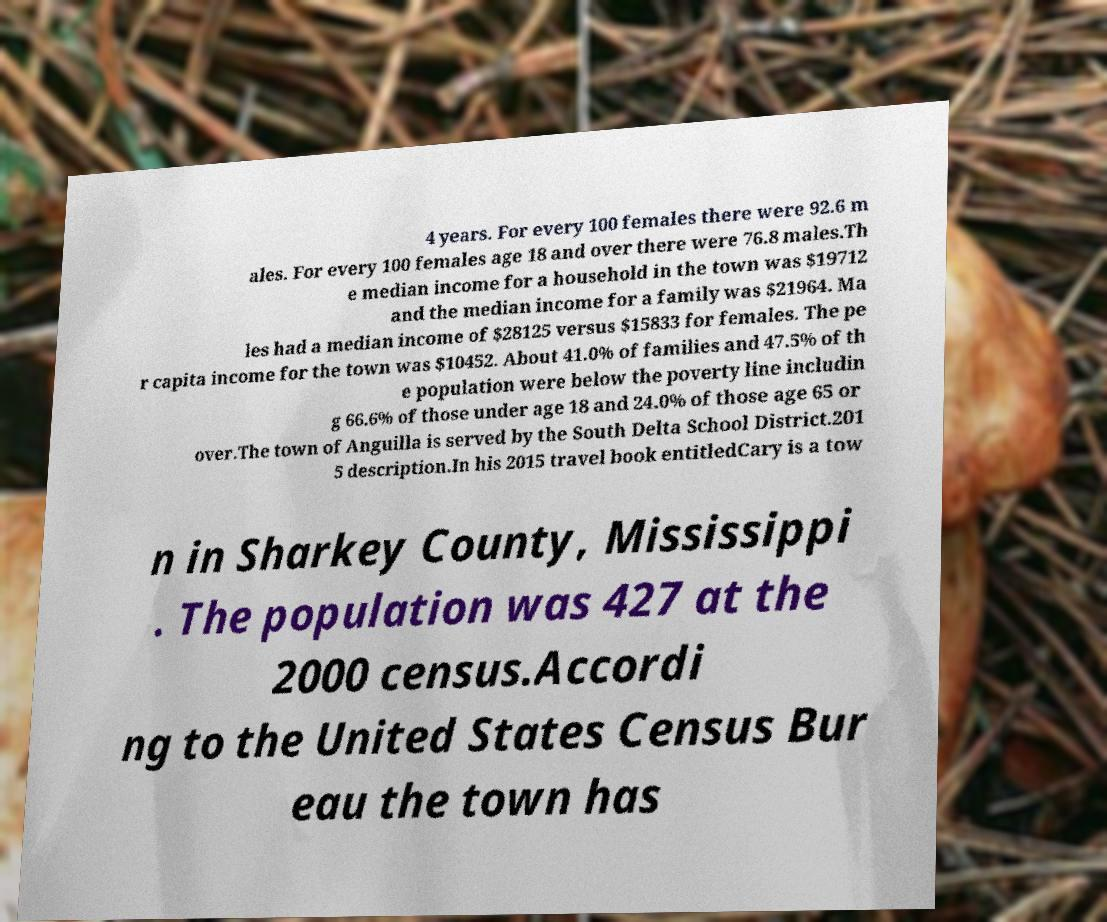What messages or text are displayed in this image? I need them in a readable, typed format. 4 years. For every 100 females there were 92.6 m ales. For every 100 females age 18 and over there were 76.8 males.Th e median income for a household in the town was $19712 and the median income for a family was $21964. Ma les had a median income of $28125 versus $15833 for females. The pe r capita income for the town was $10452. About 41.0% of families and 47.5% of th e population were below the poverty line includin g 66.6% of those under age 18 and 24.0% of those age 65 or over.The town of Anguilla is served by the South Delta School District.201 5 description.In his 2015 travel book entitledCary is a tow n in Sharkey County, Mississippi . The population was 427 at the 2000 census.Accordi ng to the United States Census Bur eau the town has 